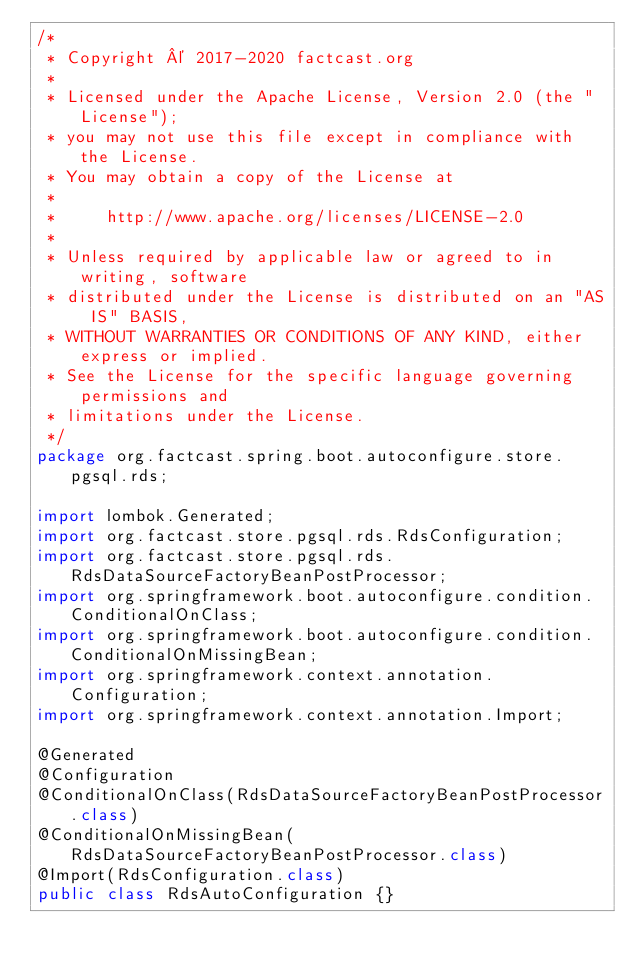Convert code to text. <code><loc_0><loc_0><loc_500><loc_500><_Java_>/*
 * Copyright © 2017-2020 factcast.org
 *
 * Licensed under the Apache License, Version 2.0 (the "License");
 * you may not use this file except in compliance with the License.
 * You may obtain a copy of the License at
 *
 *     http://www.apache.org/licenses/LICENSE-2.0
 *
 * Unless required by applicable law or agreed to in writing, software
 * distributed under the License is distributed on an "AS IS" BASIS,
 * WITHOUT WARRANTIES OR CONDITIONS OF ANY KIND, either express or implied.
 * See the License for the specific language governing permissions and
 * limitations under the License.
 */
package org.factcast.spring.boot.autoconfigure.store.pgsql.rds;

import lombok.Generated;
import org.factcast.store.pgsql.rds.RdsConfiguration;
import org.factcast.store.pgsql.rds.RdsDataSourceFactoryBeanPostProcessor;
import org.springframework.boot.autoconfigure.condition.ConditionalOnClass;
import org.springframework.boot.autoconfigure.condition.ConditionalOnMissingBean;
import org.springframework.context.annotation.Configuration;
import org.springframework.context.annotation.Import;

@Generated
@Configuration
@ConditionalOnClass(RdsDataSourceFactoryBeanPostProcessor.class)
@ConditionalOnMissingBean(RdsDataSourceFactoryBeanPostProcessor.class)
@Import(RdsConfiguration.class)
public class RdsAutoConfiguration {}
</code> 